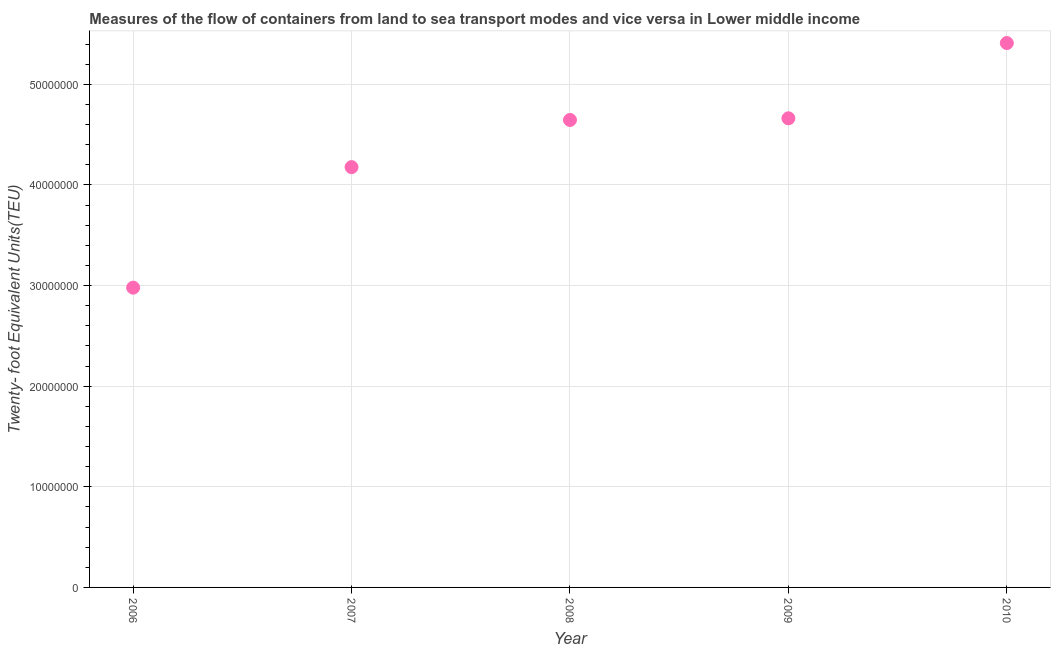What is the container port traffic in 2010?
Provide a succinct answer. 5.41e+07. Across all years, what is the maximum container port traffic?
Keep it short and to the point. 5.41e+07. Across all years, what is the minimum container port traffic?
Offer a very short reply. 2.98e+07. In which year was the container port traffic maximum?
Your answer should be very brief. 2010. In which year was the container port traffic minimum?
Your response must be concise. 2006. What is the sum of the container port traffic?
Give a very brief answer. 2.19e+08. What is the difference between the container port traffic in 2007 and 2008?
Provide a succinct answer. -4.69e+06. What is the average container port traffic per year?
Make the answer very short. 4.38e+07. What is the median container port traffic?
Ensure brevity in your answer.  4.65e+07. Do a majority of the years between 2009 and 2006 (inclusive) have container port traffic greater than 24000000 TEU?
Offer a terse response. Yes. What is the ratio of the container port traffic in 2007 to that in 2009?
Your answer should be compact. 0.9. Is the difference between the container port traffic in 2009 and 2010 greater than the difference between any two years?
Your answer should be compact. No. What is the difference between the highest and the second highest container port traffic?
Your answer should be compact. 7.48e+06. What is the difference between the highest and the lowest container port traffic?
Your answer should be very brief. 2.43e+07. Does the container port traffic monotonically increase over the years?
Offer a very short reply. Yes. How many years are there in the graph?
Your answer should be compact. 5. What is the difference between two consecutive major ticks on the Y-axis?
Your answer should be very brief. 1.00e+07. Does the graph contain any zero values?
Offer a terse response. No. What is the title of the graph?
Keep it short and to the point. Measures of the flow of containers from land to sea transport modes and vice versa in Lower middle income. What is the label or title of the X-axis?
Your answer should be very brief. Year. What is the label or title of the Y-axis?
Make the answer very short. Twenty- foot Equivalent Units(TEU). What is the Twenty- foot Equivalent Units(TEU) in 2006?
Provide a short and direct response. 2.98e+07. What is the Twenty- foot Equivalent Units(TEU) in 2007?
Your answer should be very brief. 4.18e+07. What is the Twenty- foot Equivalent Units(TEU) in 2008?
Provide a short and direct response. 4.65e+07. What is the Twenty- foot Equivalent Units(TEU) in 2009?
Offer a very short reply. 4.66e+07. What is the Twenty- foot Equivalent Units(TEU) in 2010?
Your answer should be compact. 5.41e+07. What is the difference between the Twenty- foot Equivalent Units(TEU) in 2006 and 2007?
Give a very brief answer. -1.20e+07. What is the difference between the Twenty- foot Equivalent Units(TEU) in 2006 and 2008?
Your answer should be compact. -1.67e+07. What is the difference between the Twenty- foot Equivalent Units(TEU) in 2006 and 2009?
Provide a succinct answer. -1.68e+07. What is the difference between the Twenty- foot Equivalent Units(TEU) in 2006 and 2010?
Your answer should be very brief. -2.43e+07. What is the difference between the Twenty- foot Equivalent Units(TEU) in 2007 and 2008?
Offer a terse response. -4.69e+06. What is the difference between the Twenty- foot Equivalent Units(TEU) in 2007 and 2009?
Ensure brevity in your answer.  -4.85e+06. What is the difference between the Twenty- foot Equivalent Units(TEU) in 2007 and 2010?
Your answer should be very brief. -1.23e+07. What is the difference between the Twenty- foot Equivalent Units(TEU) in 2008 and 2009?
Keep it short and to the point. -1.65e+05. What is the difference between the Twenty- foot Equivalent Units(TEU) in 2008 and 2010?
Your answer should be very brief. -7.64e+06. What is the difference between the Twenty- foot Equivalent Units(TEU) in 2009 and 2010?
Your response must be concise. -7.48e+06. What is the ratio of the Twenty- foot Equivalent Units(TEU) in 2006 to that in 2007?
Your response must be concise. 0.71. What is the ratio of the Twenty- foot Equivalent Units(TEU) in 2006 to that in 2008?
Provide a short and direct response. 0.64. What is the ratio of the Twenty- foot Equivalent Units(TEU) in 2006 to that in 2009?
Your answer should be compact. 0.64. What is the ratio of the Twenty- foot Equivalent Units(TEU) in 2006 to that in 2010?
Your response must be concise. 0.55. What is the ratio of the Twenty- foot Equivalent Units(TEU) in 2007 to that in 2008?
Keep it short and to the point. 0.9. What is the ratio of the Twenty- foot Equivalent Units(TEU) in 2007 to that in 2009?
Make the answer very short. 0.9. What is the ratio of the Twenty- foot Equivalent Units(TEU) in 2007 to that in 2010?
Your answer should be very brief. 0.77. What is the ratio of the Twenty- foot Equivalent Units(TEU) in 2008 to that in 2010?
Give a very brief answer. 0.86. What is the ratio of the Twenty- foot Equivalent Units(TEU) in 2009 to that in 2010?
Offer a terse response. 0.86. 